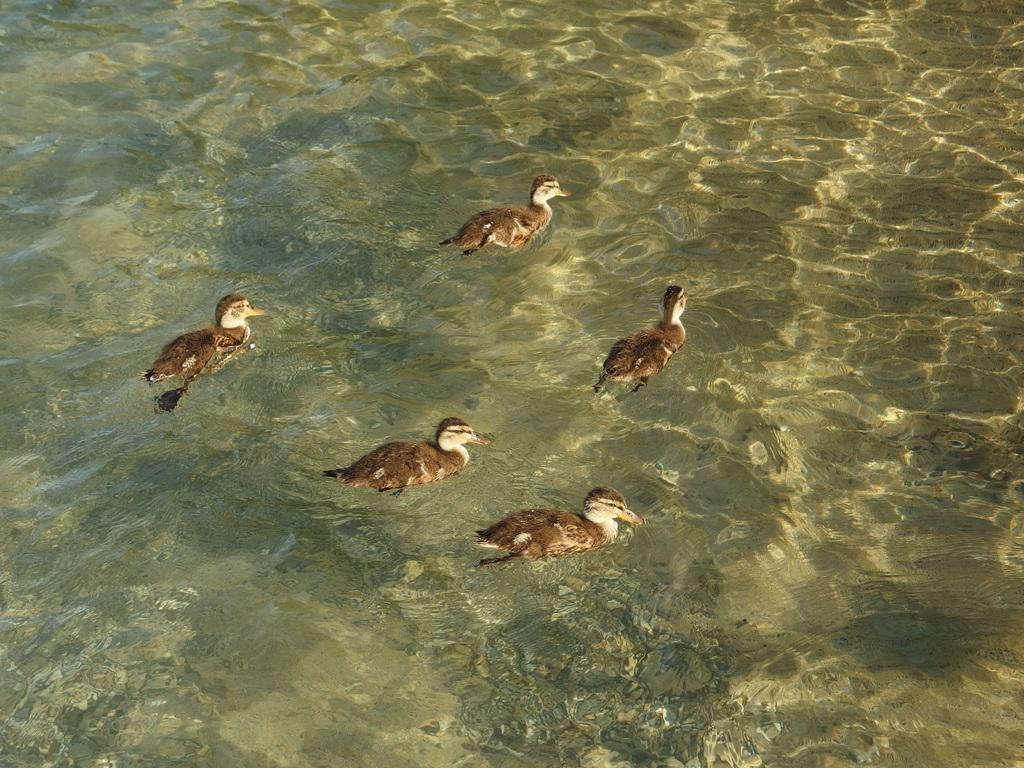What is the possible location of the image? The image might be taken at a lake. What animals can be seen in the water? There are ducks in the water. Are the ducks in any distress? The ducks are drowning, which suggests they are in distress. What can be seen in the background of the image? The background of the image includes water in the lake. What type of rod can be seen in the image? There is no rod present in the image. How many fish are visible in the image? There are no fish visible in the image; it features ducks in the water. 